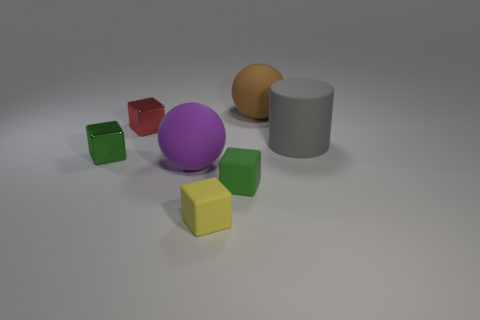The other rubber thing that is the same shape as the big purple thing is what size?
Give a very brief answer. Large. There is a small red thing left of the tiny green rubber cube; is its shape the same as the gray thing?
Your answer should be very brief. No. There is a green object behind the tiny green cube on the right side of the purple sphere; what is its shape?
Make the answer very short. Cube. Is there any other thing that has the same shape as the gray thing?
Your response must be concise. No. There is another large matte thing that is the same shape as the brown object; what is its color?
Keep it short and to the point. Purple. There is a large object that is both in front of the brown rubber object and left of the gray matte thing; what shape is it?
Keep it short and to the point. Sphere. Is the number of purple spheres less than the number of tiny metallic cubes?
Keep it short and to the point. Yes. Is there a tiny purple rubber cube?
Your response must be concise. No. How many other things are the same size as the green metallic object?
Offer a very short reply. 3. Is the purple object made of the same material as the small object that is on the right side of the tiny yellow cube?
Ensure brevity in your answer.  Yes. 